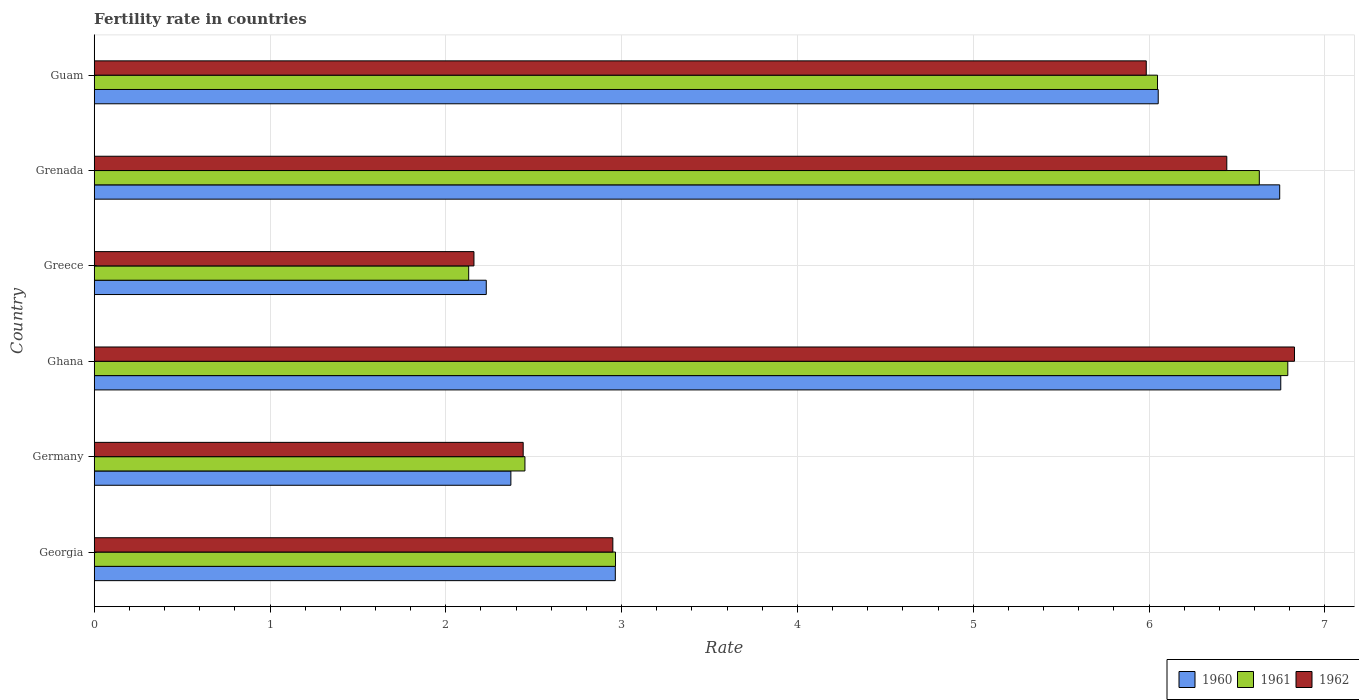How many different coloured bars are there?
Offer a terse response. 3. How many groups of bars are there?
Your response must be concise. 6. Are the number of bars per tick equal to the number of legend labels?
Make the answer very short. Yes. Are the number of bars on each tick of the Y-axis equal?
Make the answer very short. Yes. How many bars are there on the 4th tick from the top?
Keep it short and to the point. 3. How many bars are there on the 5th tick from the bottom?
Make the answer very short. 3. What is the label of the 4th group of bars from the top?
Provide a short and direct response. Ghana. What is the fertility rate in 1962 in Georgia?
Offer a very short reply. 2.95. Across all countries, what is the maximum fertility rate in 1962?
Make the answer very short. 6.83. Across all countries, what is the minimum fertility rate in 1961?
Provide a short and direct response. 2.13. In which country was the fertility rate in 1962 minimum?
Offer a terse response. Greece. What is the total fertility rate in 1960 in the graph?
Provide a short and direct response. 27.11. What is the difference between the fertility rate in 1961 in Ghana and that in Guam?
Offer a very short reply. 0.74. What is the difference between the fertility rate in 1960 in Grenada and the fertility rate in 1961 in Ghana?
Give a very brief answer. -0.05. What is the average fertility rate in 1962 per country?
Provide a short and direct response. 4.47. What is the difference between the fertility rate in 1960 and fertility rate in 1961 in Germany?
Make the answer very short. -0.08. What is the ratio of the fertility rate in 1960 in Georgia to that in Guam?
Offer a terse response. 0.49. Is the fertility rate in 1961 in Georgia less than that in Guam?
Keep it short and to the point. Yes. Is the difference between the fertility rate in 1960 in Ghana and Grenada greater than the difference between the fertility rate in 1961 in Ghana and Grenada?
Offer a terse response. No. What is the difference between the highest and the second highest fertility rate in 1962?
Offer a terse response. 0.39. What is the difference between the highest and the lowest fertility rate in 1961?
Provide a short and direct response. 4.66. In how many countries, is the fertility rate in 1961 greater than the average fertility rate in 1961 taken over all countries?
Give a very brief answer. 3. What does the 3rd bar from the top in Greece represents?
Keep it short and to the point. 1960. What does the 3rd bar from the bottom in Germany represents?
Your response must be concise. 1962. Is it the case that in every country, the sum of the fertility rate in 1961 and fertility rate in 1962 is greater than the fertility rate in 1960?
Ensure brevity in your answer.  Yes. How many bars are there?
Provide a short and direct response. 18. Are all the bars in the graph horizontal?
Give a very brief answer. Yes. Does the graph contain grids?
Give a very brief answer. Yes. Where does the legend appear in the graph?
Your response must be concise. Bottom right. What is the title of the graph?
Your answer should be compact. Fertility rate in countries. Does "1993" appear as one of the legend labels in the graph?
Your response must be concise. No. What is the label or title of the X-axis?
Provide a succinct answer. Rate. What is the Rate in 1960 in Georgia?
Your answer should be compact. 2.96. What is the Rate in 1961 in Georgia?
Your response must be concise. 2.96. What is the Rate of 1962 in Georgia?
Ensure brevity in your answer.  2.95. What is the Rate in 1960 in Germany?
Your answer should be compact. 2.37. What is the Rate of 1961 in Germany?
Give a very brief answer. 2.45. What is the Rate of 1962 in Germany?
Offer a terse response. 2.44. What is the Rate of 1960 in Ghana?
Provide a succinct answer. 6.75. What is the Rate in 1961 in Ghana?
Your answer should be compact. 6.79. What is the Rate of 1962 in Ghana?
Provide a succinct answer. 6.83. What is the Rate in 1960 in Greece?
Your answer should be very brief. 2.23. What is the Rate in 1961 in Greece?
Your answer should be compact. 2.13. What is the Rate in 1962 in Greece?
Offer a terse response. 2.16. What is the Rate in 1960 in Grenada?
Offer a very short reply. 6.74. What is the Rate in 1961 in Grenada?
Keep it short and to the point. 6.63. What is the Rate in 1962 in Grenada?
Give a very brief answer. 6.44. What is the Rate in 1960 in Guam?
Ensure brevity in your answer.  6.05. What is the Rate of 1961 in Guam?
Offer a very short reply. 6.05. What is the Rate in 1962 in Guam?
Give a very brief answer. 5.98. Across all countries, what is the maximum Rate in 1960?
Offer a very short reply. 6.75. Across all countries, what is the maximum Rate in 1961?
Provide a succinct answer. 6.79. Across all countries, what is the maximum Rate in 1962?
Your answer should be compact. 6.83. Across all countries, what is the minimum Rate in 1960?
Give a very brief answer. 2.23. Across all countries, what is the minimum Rate of 1961?
Offer a terse response. 2.13. Across all countries, what is the minimum Rate of 1962?
Ensure brevity in your answer.  2.16. What is the total Rate of 1960 in the graph?
Your answer should be compact. 27.11. What is the total Rate in 1961 in the graph?
Offer a very short reply. 27.01. What is the total Rate in 1962 in the graph?
Offer a very short reply. 26.8. What is the difference between the Rate of 1960 in Georgia and that in Germany?
Provide a succinct answer. 0.59. What is the difference between the Rate of 1961 in Georgia and that in Germany?
Provide a short and direct response. 0.52. What is the difference between the Rate in 1962 in Georgia and that in Germany?
Your answer should be very brief. 0.51. What is the difference between the Rate in 1960 in Georgia and that in Ghana?
Give a very brief answer. -3.79. What is the difference between the Rate in 1961 in Georgia and that in Ghana?
Your response must be concise. -3.82. What is the difference between the Rate of 1962 in Georgia and that in Ghana?
Ensure brevity in your answer.  -3.88. What is the difference between the Rate of 1960 in Georgia and that in Greece?
Give a very brief answer. 0.73. What is the difference between the Rate in 1961 in Georgia and that in Greece?
Your answer should be compact. 0.83. What is the difference between the Rate in 1962 in Georgia and that in Greece?
Make the answer very short. 0.79. What is the difference between the Rate in 1960 in Georgia and that in Grenada?
Your response must be concise. -3.78. What is the difference between the Rate of 1961 in Georgia and that in Grenada?
Your answer should be compact. -3.66. What is the difference between the Rate of 1962 in Georgia and that in Grenada?
Your answer should be very brief. -3.49. What is the difference between the Rate in 1960 in Georgia and that in Guam?
Your answer should be very brief. -3.09. What is the difference between the Rate of 1961 in Georgia and that in Guam?
Keep it short and to the point. -3.08. What is the difference between the Rate in 1962 in Georgia and that in Guam?
Make the answer very short. -3.03. What is the difference between the Rate of 1960 in Germany and that in Ghana?
Keep it short and to the point. -4.38. What is the difference between the Rate of 1961 in Germany and that in Ghana?
Offer a very short reply. -4.34. What is the difference between the Rate in 1962 in Germany and that in Ghana?
Provide a succinct answer. -4.39. What is the difference between the Rate of 1960 in Germany and that in Greece?
Ensure brevity in your answer.  0.14. What is the difference between the Rate of 1961 in Germany and that in Greece?
Keep it short and to the point. 0.32. What is the difference between the Rate of 1962 in Germany and that in Greece?
Your answer should be compact. 0.28. What is the difference between the Rate in 1960 in Germany and that in Grenada?
Provide a succinct answer. -4.37. What is the difference between the Rate of 1961 in Germany and that in Grenada?
Offer a terse response. -4.18. What is the difference between the Rate in 1962 in Germany and that in Grenada?
Ensure brevity in your answer.  -4. What is the difference between the Rate of 1960 in Germany and that in Guam?
Your answer should be very brief. -3.68. What is the difference between the Rate of 1961 in Germany and that in Guam?
Give a very brief answer. -3.6. What is the difference between the Rate of 1962 in Germany and that in Guam?
Give a very brief answer. -3.54. What is the difference between the Rate in 1960 in Ghana and that in Greece?
Provide a short and direct response. 4.52. What is the difference between the Rate of 1961 in Ghana and that in Greece?
Your answer should be very brief. 4.66. What is the difference between the Rate of 1962 in Ghana and that in Greece?
Provide a succinct answer. 4.67. What is the difference between the Rate of 1960 in Ghana and that in Grenada?
Offer a terse response. 0.01. What is the difference between the Rate of 1961 in Ghana and that in Grenada?
Keep it short and to the point. 0.16. What is the difference between the Rate in 1962 in Ghana and that in Grenada?
Provide a short and direct response. 0.39. What is the difference between the Rate of 1960 in Ghana and that in Guam?
Your answer should be compact. 0.7. What is the difference between the Rate of 1961 in Ghana and that in Guam?
Make the answer very short. 0.74. What is the difference between the Rate of 1962 in Ghana and that in Guam?
Your answer should be very brief. 0.84. What is the difference between the Rate of 1960 in Greece and that in Grenada?
Offer a very short reply. -4.51. What is the difference between the Rate in 1961 in Greece and that in Grenada?
Your answer should be compact. -4.5. What is the difference between the Rate of 1962 in Greece and that in Grenada?
Ensure brevity in your answer.  -4.28. What is the difference between the Rate in 1960 in Greece and that in Guam?
Your response must be concise. -3.82. What is the difference between the Rate of 1961 in Greece and that in Guam?
Provide a succinct answer. -3.92. What is the difference between the Rate of 1962 in Greece and that in Guam?
Provide a short and direct response. -3.82. What is the difference between the Rate of 1960 in Grenada and that in Guam?
Offer a terse response. 0.69. What is the difference between the Rate of 1961 in Grenada and that in Guam?
Make the answer very short. 0.58. What is the difference between the Rate in 1962 in Grenada and that in Guam?
Your response must be concise. 0.46. What is the difference between the Rate in 1960 in Georgia and the Rate in 1961 in Germany?
Your answer should be compact. 0.51. What is the difference between the Rate of 1960 in Georgia and the Rate of 1962 in Germany?
Offer a terse response. 0.52. What is the difference between the Rate of 1961 in Georgia and the Rate of 1962 in Germany?
Provide a succinct answer. 0.53. What is the difference between the Rate in 1960 in Georgia and the Rate in 1961 in Ghana?
Provide a succinct answer. -3.83. What is the difference between the Rate in 1960 in Georgia and the Rate in 1962 in Ghana?
Your answer should be compact. -3.86. What is the difference between the Rate of 1961 in Georgia and the Rate of 1962 in Ghana?
Your response must be concise. -3.86. What is the difference between the Rate in 1960 in Georgia and the Rate in 1961 in Greece?
Keep it short and to the point. 0.83. What is the difference between the Rate of 1960 in Georgia and the Rate of 1962 in Greece?
Keep it short and to the point. 0.8. What is the difference between the Rate of 1961 in Georgia and the Rate of 1962 in Greece?
Ensure brevity in your answer.  0.81. What is the difference between the Rate of 1960 in Georgia and the Rate of 1961 in Grenada?
Make the answer very short. -3.66. What is the difference between the Rate in 1960 in Georgia and the Rate in 1962 in Grenada?
Your answer should be compact. -3.48. What is the difference between the Rate of 1961 in Georgia and the Rate of 1962 in Grenada?
Keep it short and to the point. -3.48. What is the difference between the Rate in 1960 in Georgia and the Rate in 1961 in Guam?
Give a very brief answer. -3.08. What is the difference between the Rate of 1960 in Georgia and the Rate of 1962 in Guam?
Offer a terse response. -3.02. What is the difference between the Rate of 1961 in Georgia and the Rate of 1962 in Guam?
Provide a short and direct response. -3.02. What is the difference between the Rate in 1960 in Germany and the Rate in 1961 in Ghana?
Your answer should be compact. -4.42. What is the difference between the Rate in 1960 in Germany and the Rate in 1962 in Ghana?
Offer a terse response. -4.46. What is the difference between the Rate in 1961 in Germany and the Rate in 1962 in Ghana?
Offer a terse response. -4.38. What is the difference between the Rate of 1960 in Germany and the Rate of 1961 in Greece?
Keep it short and to the point. 0.24. What is the difference between the Rate of 1960 in Germany and the Rate of 1962 in Greece?
Ensure brevity in your answer.  0.21. What is the difference between the Rate in 1961 in Germany and the Rate in 1962 in Greece?
Offer a terse response. 0.29. What is the difference between the Rate in 1960 in Germany and the Rate in 1961 in Grenada?
Provide a short and direct response. -4.26. What is the difference between the Rate of 1960 in Germany and the Rate of 1962 in Grenada?
Give a very brief answer. -4.07. What is the difference between the Rate of 1961 in Germany and the Rate of 1962 in Grenada?
Keep it short and to the point. -3.99. What is the difference between the Rate in 1960 in Germany and the Rate in 1961 in Guam?
Your answer should be very brief. -3.68. What is the difference between the Rate in 1960 in Germany and the Rate in 1962 in Guam?
Give a very brief answer. -3.61. What is the difference between the Rate of 1961 in Germany and the Rate of 1962 in Guam?
Offer a terse response. -3.53. What is the difference between the Rate of 1960 in Ghana and the Rate of 1961 in Greece?
Your response must be concise. 4.62. What is the difference between the Rate of 1960 in Ghana and the Rate of 1962 in Greece?
Your answer should be compact. 4.59. What is the difference between the Rate in 1961 in Ghana and the Rate in 1962 in Greece?
Make the answer very short. 4.63. What is the difference between the Rate in 1960 in Ghana and the Rate in 1961 in Grenada?
Give a very brief answer. 0.12. What is the difference between the Rate in 1960 in Ghana and the Rate in 1962 in Grenada?
Your response must be concise. 0.31. What is the difference between the Rate in 1961 in Ghana and the Rate in 1962 in Grenada?
Ensure brevity in your answer.  0.35. What is the difference between the Rate of 1960 in Ghana and the Rate of 1961 in Guam?
Give a very brief answer. 0.7. What is the difference between the Rate in 1960 in Ghana and the Rate in 1962 in Guam?
Ensure brevity in your answer.  0.77. What is the difference between the Rate of 1961 in Ghana and the Rate of 1962 in Guam?
Make the answer very short. 0.81. What is the difference between the Rate of 1960 in Greece and the Rate of 1961 in Grenada?
Your answer should be compact. -4.4. What is the difference between the Rate of 1960 in Greece and the Rate of 1962 in Grenada?
Provide a short and direct response. -4.21. What is the difference between the Rate in 1961 in Greece and the Rate in 1962 in Grenada?
Give a very brief answer. -4.31. What is the difference between the Rate of 1960 in Greece and the Rate of 1961 in Guam?
Provide a short and direct response. -3.82. What is the difference between the Rate in 1960 in Greece and the Rate in 1962 in Guam?
Your answer should be compact. -3.75. What is the difference between the Rate in 1961 in Greece and the Rate in 1962 in Guam?
Provide a succinct answer. -3.85. What is the difference between the Rate in 1960 in Grenada and the Rate in 1961 in Guam?
Offer a very short reply. 0.69. What is the difference between the Rate in 1960 in Grenada and the Rate in 1962 in Guam?
Keep it short and to the point. 0.76. What is the difference between the Rate in 1961 in Grenada and the Rate in 1962 in Guam?
Your answer should be very brief. 0.64. What is the average Rate of 1960 per country?
Provide a succinct answer. 4.52. What is the average Rate in 1961 per country?
Offer a very short reply. 4.5. What is the average Rate of 1962 per country?
Your answer should be compact. 4.47. What is the difference between the Rate in 1960 and Rate in 1961 in Georgia?
Give a very brief answer. -0. What is the difference between the Rate in 1960 and Rate in 1962 in Georgia?
Your response must be concise. 0.01. What is the difference between the Rate of 1961 and Rate of 1962 in Georgia?
Keep it short and to the point. 0.01. What is the difference between the Rate in 1960 and Rate in 1961 in Germany?
Offer a very short reply. -0.08. What is the difference between the Rate of 1960 and Rate of 1962 in Germany?
Make the answer very short. -0.07. What is the difference between the Rate in 1961 and Rate in 1962 in Germany?
Provide a short and direct response. 0.01. What is the difference between the Rate in 1960 and Rate in 1961 in Ghana?
Keep it short and to the point. -0.04. What is the difference between the Rate in 1960 and Rate in 1962 in Ghana?
Make the answer very short. -0.08. What is the difference between the Rate of 1961 and Rate of 1962 in Ghana?
Your answer should be compact. -0.04. What is the difference between the Rate in 1960 and Rate in 1962 in Greece?
Your response must be concise. 0.07. What is the difference between the Rate of 1961 and Rate of 1962 in Greece?
Make the answer very short. -0.03. What is the difference between the Rate of 1960 and Rate of 1961 in Grenada?
Keep it short and to the point. 0.12. What is the difference between the Rate in 1960 and Rate in 1962 in Grenada?
Provide a short and direct response. 0.3. What is the difference between the Rate in 1961 and Rate in 1962 in Grenada?
Give a very brief answer. 0.18. What is the difference between the Rate in 1960 and Rate in 1961 in Guam?
Give a very brief answer. 0. What is the difference between the Rate of 1960 and Rate of 1962 in Guam?
Make the answer very short. 0.07. What is the difference between the Rate of 1961 and Rate of 1962 in Guam?
Make the answer very short. 0.06. What is the ratio of the Rate of 1960 in Georgia to that in Germany?
Ensure brevity in your answer.  1.25. What is the ratio of the Rate of 1961 in Georgia to that in Germany?
Your answer should be very brief. 1.21. What is the ratio of the Rate of 1962 in Georgia to that in Germany?
Provide a succinct answer. 1.21. What is the ratio of the Rate of 1960 in Georgia to that in Ghana?
Provide a short and direct response. 0.44. What is the ratio of the Rate of 1961 in Georgia to that in Ghana?
Your answer should be compact. 0.44. What is the ratio of the Rate of 1962 in Georgia to that in Ghana?
Make the answer very short. 0.43. What is the ratio of the Rate in 1960 in Georgia to that in Greece?
Provide a succinct answer. 1.33. What is the ratio of the Rate in 1961 in Georgia to that in Greece?
Offer a terse response. 1.39. What is the ratio of the Rate in 1962 in Georgia to that in Greece?
Ensure brevity in your answer.  1.37. What is the ratio of the Rate in 1960 in Georgia to that in Grenada?
Offer a terse response. 0.44. What is the ratio of the Rate in 1961 in Georgia to that in Grenada?
Offer a very short reply. 0.45. What is the ratio of the Rate in 1962 in Georgia to that in Grenada?
Give a very brief answer. 0.46. What is the ratio of the Rate in 1960 in Georgia to that in Guam?
Your answer should be compact. 0.49. What is the ratio of the Rate in 1961 in Georgia to that in Guam?
Your answer should be compact. 0.49. What is the ratio of the Rate of 1962 in Georgia to that in Guam?
Provide a succinct answer. 0.49. What is the ratio of the Rate of 1960 in Germany to that in Ghana?
Ensure brevity in your answer.  0.35. What is the ratio of the Rate of 1961 in Germany to that in Ghana?
Make the answer very short. 0.36. What is the ratio of the Rate of 1962 in Germany to that in Ghana?
Your answer should be very brief. 0.36. What is the ratio of the Rate in 1960 in Germany to that in Greece?
Offer a very short reply. 1.06. What is the ratio of the Rate in 1961 in Germany to that in Greece?
Your answer should be compact. 1.15. What is the ratio of the Rate in 1962 in Germany to that in Greece?
Offer a terse response. 1.13. What is the ratio of the Rate in 1960 in Germany to that in Grenada?
Keep it short and to the point. 0.35. What is the ratio of the Rate in 1961 in Germany to that in Grenada?
Make the answer very short. 0.37. What is the ratio of the Rate of 1962 in Germany to that in Grenada?
Keep it short and to the point. 0.38. What is the ratio of the Rate of 1960 in Germany to that in Guam?
Your response must be concise. 0.39. What is the ratio of the Rate of 1961 in Germany to that in Guam?
Your response must be concise. 0.41. What is the ratio of the Rate of 1962 in Germany to that in Guam?
Your answer should be compact. 0.41. What is the ratio of the Rate in 1960 in Ghana to that in Greece?
Offer a very short reply. 3.03. What is the ratio of the Rate in 1961 in Ghana to that in Greece?
Give a very brief answer. 3.19. What is the ratio of the Rate in 1962 in Ghana to that in Greece?
Give a very brief answer. 3.16. What is the ratio of the Rate in 1961 in Ghana to that in Grenada?
Give a very brief answer. 1.02. What is the ratio of the Rate in 1962 in Ghana to that in Grenada?
Your answer should be compact. 1.06. What is the ratio of the Rate in 1960 in Ghana to that in Guam?
Your answer should be very brief. 1.12. What is the ratio of the Rate in 1961 in Ghana to that in Guam?
Your answer should be very brief. 1.12. What is the ratio of the Rate of 1962 in Ghana to that in Guam?
Provide a succinct answer. 1.14. What is the ratio of the Rate of 1960 in Greece to that in Grenada?
Provide a succinct answer. 0.33. What is the ratio of the Rate in 1961 in Greece to that in Grenada?
Make the answer very short. 0.32. What is the ratio of the Rate in 1962 in Greece to that in Grenada?
Provide a succinct answer. 0.34. What is the ratio of the Rate in 1960 in Greece to that in Guam?
Offer a very short reply. 0.37. What is the ratio of the Rate of 1961 in Greece to that in Guam?
Provide a succinct answer. 0.35. What is the ratio of the Rate in 1962 in Greece to that in Guam?
Offer a very short reply. 0.36. What is the ratio of the Rate in 1960 in Grenada to that in Guam?
Your answer should be very brief. 1.11. What is the ratio of the Rate in 1961 in Grenada to that in Guam?
Your answer should be very brief. 1.1. What is the ratio of the Rate in 1962 in Grenada to that in Guam?
Give a very brief answer. 1.08. What is the difference between the highest and the second highest Rate of 1960?
Your answer should be compact. 0.01. What is the difference between the highest and the second highest Rate of 1961?
Provide a succinct answer. 0.16. What is the difference between the highest and the second highest Rate of 1962?
Ensure brevity in your answer.  0.39. What is the difference between the highest and the lowest Rate of 1960?
Ensure brevity in your answer.  4.52. What is the difference between the highest and the lowest Rate in 1961?
Your answer should be compact. 4.66. What is the difference between the highest and the lowest Rate in 1962?
Keep it short and to the point. 4.67. 